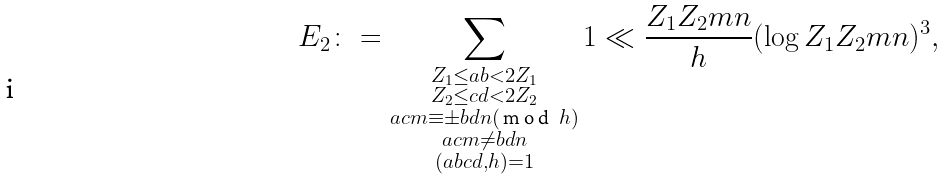Convert formula to latex. <formula><loc_0><loc_0><loc_500><loc_500>E _ { 2 } \colon = \sum _ { \substack { Z _ { 1 } \leq a b < 2 Z _ { 1 } \\ Z _ { 2 } \leq c d < 2 Z _ { 2 } \\ a c m \equiv \pm b d n ( \emph { m o d } \ h ) \\ a c m \ne b d n \\ ( a b c d , h ) = 1 } } 1 \ll \frac { Z _ { 1 } Z _ { 2 } m n } { h } ( \log Z _ { 1 } Z _ { 2 } m n ) ^ { 3 } ,</formula> 